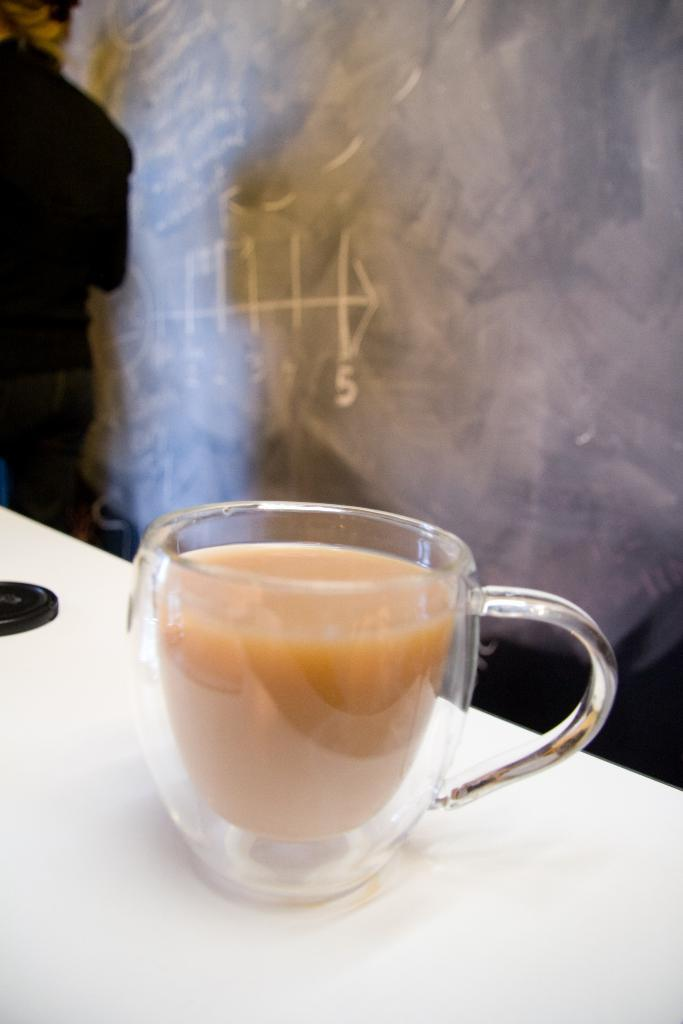What is the main object in the center of the image? There is a coffee cup in the center of the image. Where is the coffee cup placed? The coffee cup is on a table. Can you describe the background of the image? There is a person standing in the background of the image, and there is a wall visible as well. What type of ink is being used by the duck in the image? There is no duck present in the image, and therefore no ink or writing can be observed. 